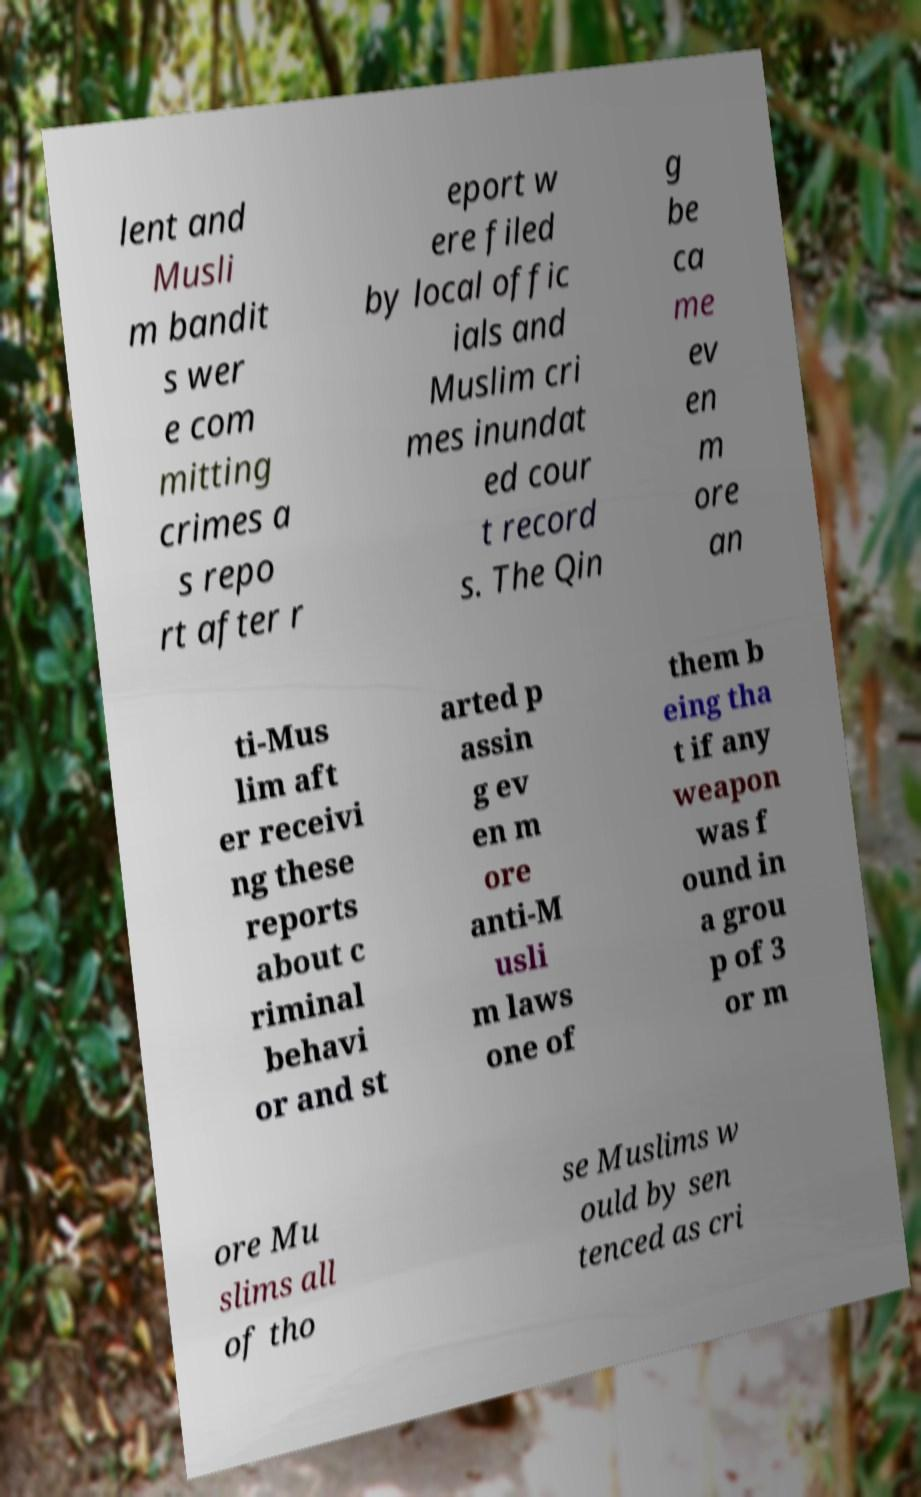I need the written content from this picture converted into text. Can you do that? lent and Musli m bandit s wer e com mitting crimes a s repo rt after r eport w ere filed by local offic ials and Muslim cri mes inundat ed cour t record s. The Qin g be ca me ev en m ore an ti-Mus lim aft er receivi ng these reports about c riminal behavi or and st arted p assin g ev en m ore anti-M usli m laws one of them b eing tha t if any weapon was f ound in a grou p of 3 or m ore Mu slims all of tho se Muslims w ould by sen tenced as cri 